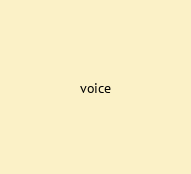Convert code to text. <code><loc_0><loc_0><loc_500><loc_500><_Ruby_>voice</code> 